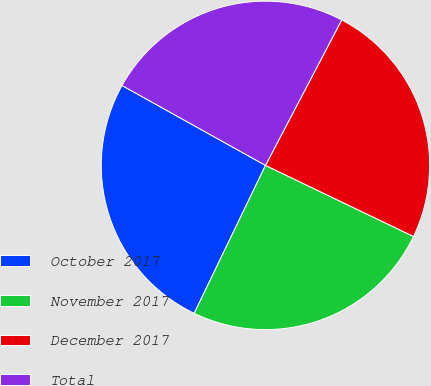Convert chart. <chart><loc_0><loc_0><loc_500><loc_500><pie_chart><fcel>October 2017<fcel>November 2017<fcel>December 2017<fcel>Total<nl><fcel>25.94%<fcel>25.02%<fcel>24.44%<fcel>24.59%<nl></chart> 